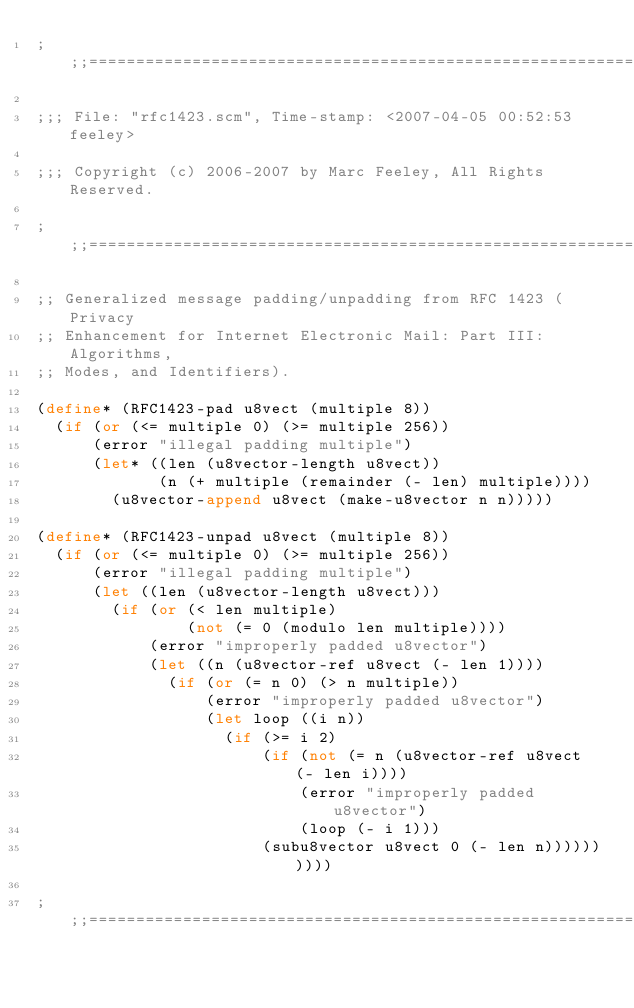Convert code to text. <code><loc_0><loc_0><loc_500><loc_500><_Scheme_>;;;============================================================================

;;; File: "rfc1423.scm", Time-stamp: <2007-04-05 00:52:53 feeley>

;;; Copyright (c) 2006-2007 by Marc Feeley, All Rights Reserved.

;;;============================================================================

;; Generalized message padding/unpadding from RFC 1423 (Privacy
;; Enhancement for Internet Electronic Mail: Part III: Algorithms,
;; Modes, and Identifiers).

(define* (RFC1423-pad u8vect (multiple 8))
  (if (or (<= multiple 0) (>= multiple 256))
      (error "illegal padding multiple")
      (let* ((len (u8vector-length u8vect))
             (n (+ multiple (remainder (- len) multiple))))
        (u8vector-append u8vect (make-u8vector n n)))))

(define* (RFC1423-unpad u8vect (multiple 8))
  (if (or (<= multiple 0) (>= multiple 256))
      (error "illegal padding multiple")
      (let ((len (u8vector-length u8vect)))
        (if (or (< len multiple)
                (not (= 0 (modulo len multiple))))
            (error "improperly padded u8vector")
            (let ((n (u8vector-ref u8vect (- len 1))))
              (if (or (= n 0) (> n multiple))
                  (error "improperly padded u8vector")
                  (let loop ((i n))
                    (if (>= i 2)
                        (if (not (= n (u8vector-ref u8vect (- len i))))
                            (error "improperly padded u8vector")
                            (loop (- i 1)))
                        (subu8vector u8vect 0 (- len n))))))))))

;;;============================================================================
</code> 